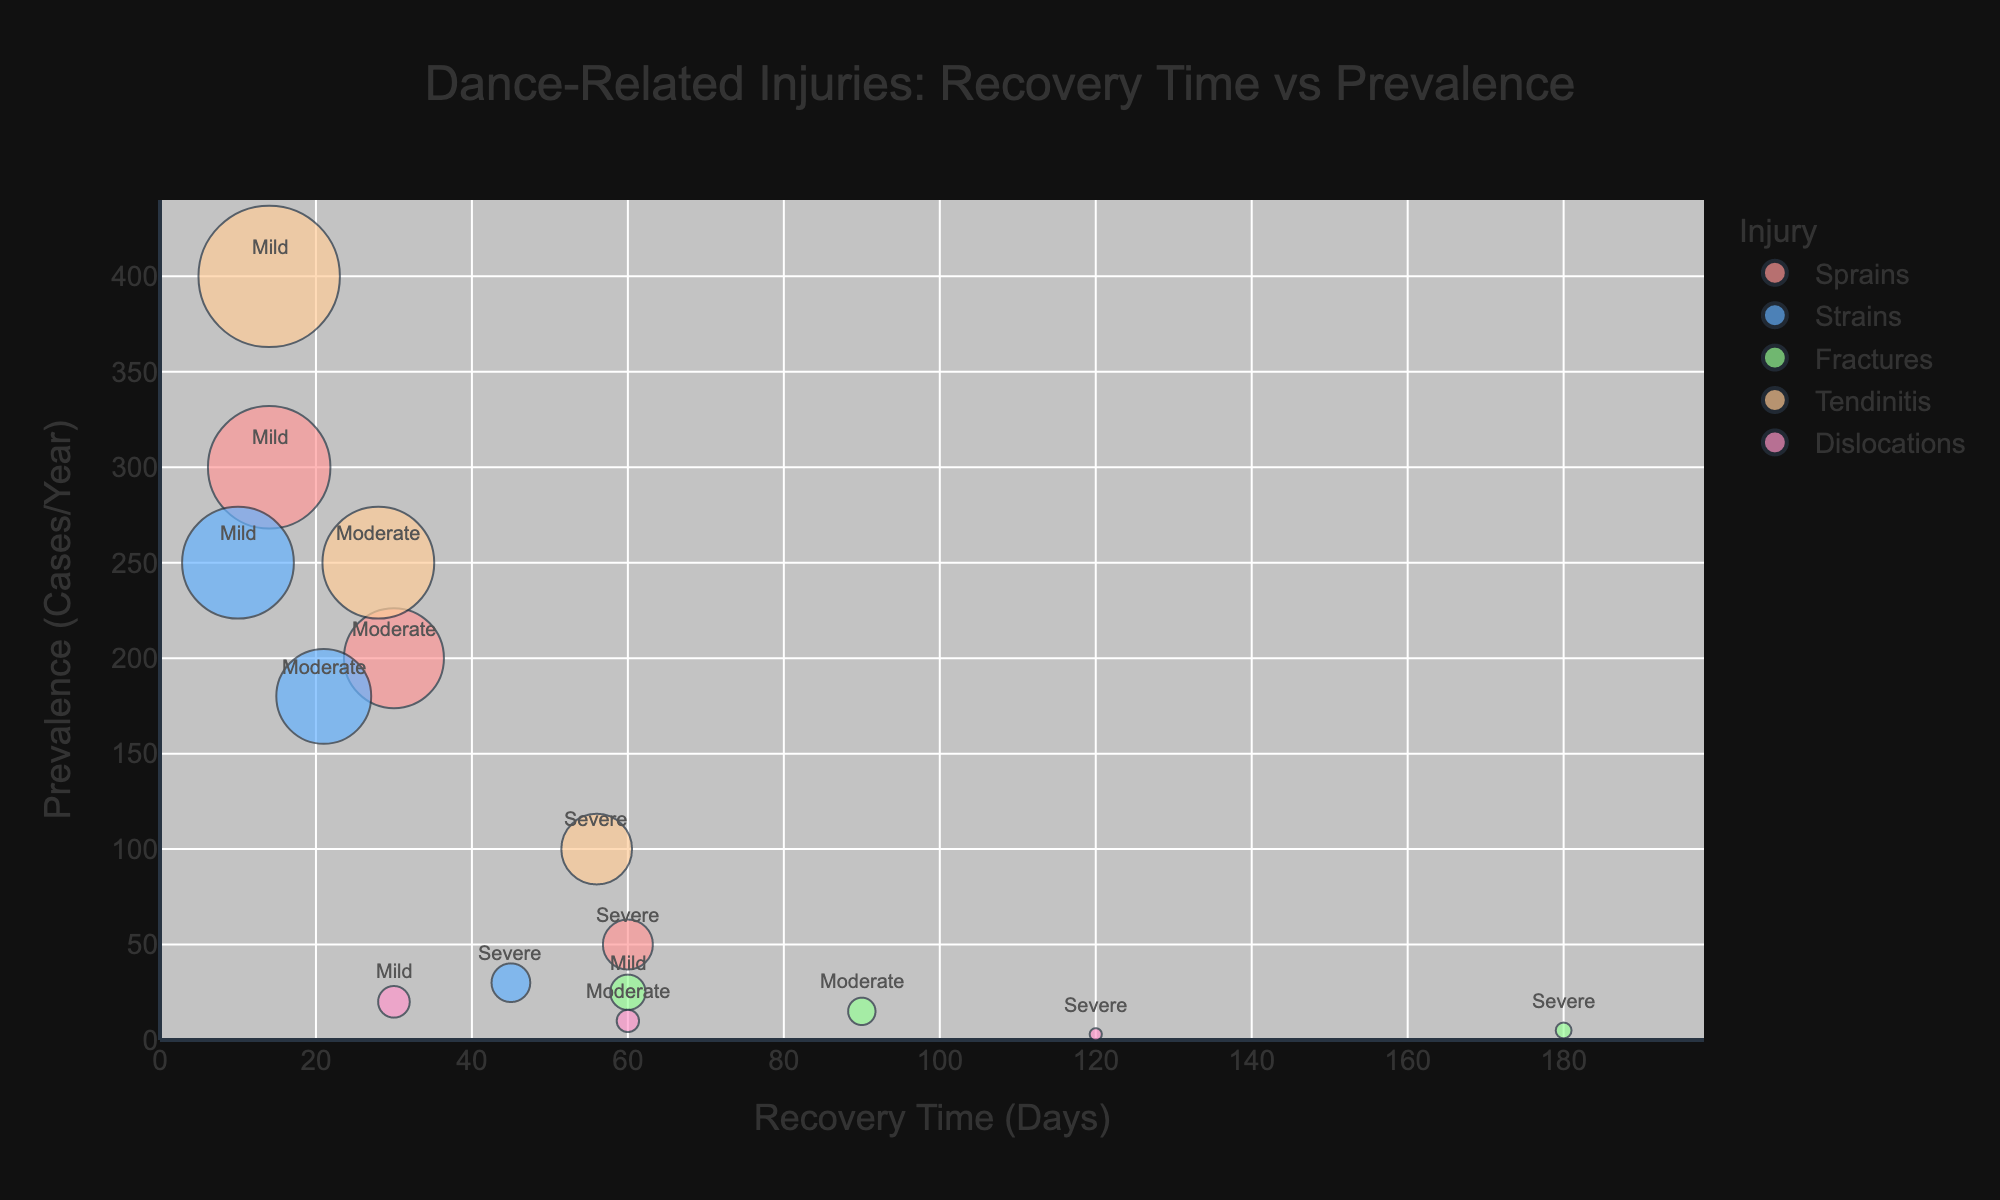What's the title of the figure? The title of the figure is displayed at the top and usually summarizes the main purpose of the chart. From the given data, the title is "Dance-Related Injuries: Recovery Time vs Prevalence".
Answer: Dance-Related Injuries: Recovery Time vs Prevalence Which injury has the highest prevalence among dancers? To determine the highest prevalence injury, look at the y-axis for the largest value. The injury with the largest circle on the y-axis is "Tendinitis" with a prevalence of 400 cases/year.
Answer: Tendinitis What is the recovery time for moderate sprains? Locate the data points labeled as "Sprains" and check the annotations for the severity "Moderate". The recovery time for moderate sprains is found at the point marked 30 days.
Answer: 30 days Between strains and dislocations, which has a shorter recovery time for mild cases? Identify the "Strains" and "Dislocations" on the x-axis with severity "Mild". "Strains" have a recovery time of 10 days and "Dislocations" have a recovery time of 30 days. Therefore, strains have a shorter recovery time.
Answer: Strains What is the average recovery time for severe injuries? Add the recovery times for severe injuries for each type of injury: 60 (Sprains) + 45 (Strains) + 180 (Fractures) + 56 (Tendinitis) + 120 (Dislocations) = 461. Divide by the number of injuries (5), the average recovery time is 461 / 5.
Answer: 92.2 days Which injury type has the most severe cases with recovery time greater than 100 days? Look for injury types with "Severe" annotation and recovery times greater than 100 days. "Fractures" (180 days) and "Dislocations" (120 days) qualify, with fractures having a higher count of severe cases.
Answer: Fractures What is the range of recovery times for tendinitis? Identify the recovery times for tendinitis across all severities: 14 (Mild), 28 (Moderate), 56 (Severe). The range is calculated as the difference between the maximum and minimum recovery times (56 - 14).
Answer: 42 days Which severity level of injuries is most prevalent among dancers? Look at the severity labels near the largest circles. For highest prevalence, the "Mild" annotation circles (Tendinitis with 400 cases and Sprains with 300 cases) dominate the chart. Therefore, mild injuries are most prevalent.
Answer: Mild How does the prevalence of severe strains compare to severe sprains? Locate the circles for severe strains and severe sprains, and compare their y-axis values. Severe strains have a prevalence of 30 cases/year while severe sprains have 50 cases/year. Thus, severe sprains have a higher prevalence.
Answer: Severe sprains 